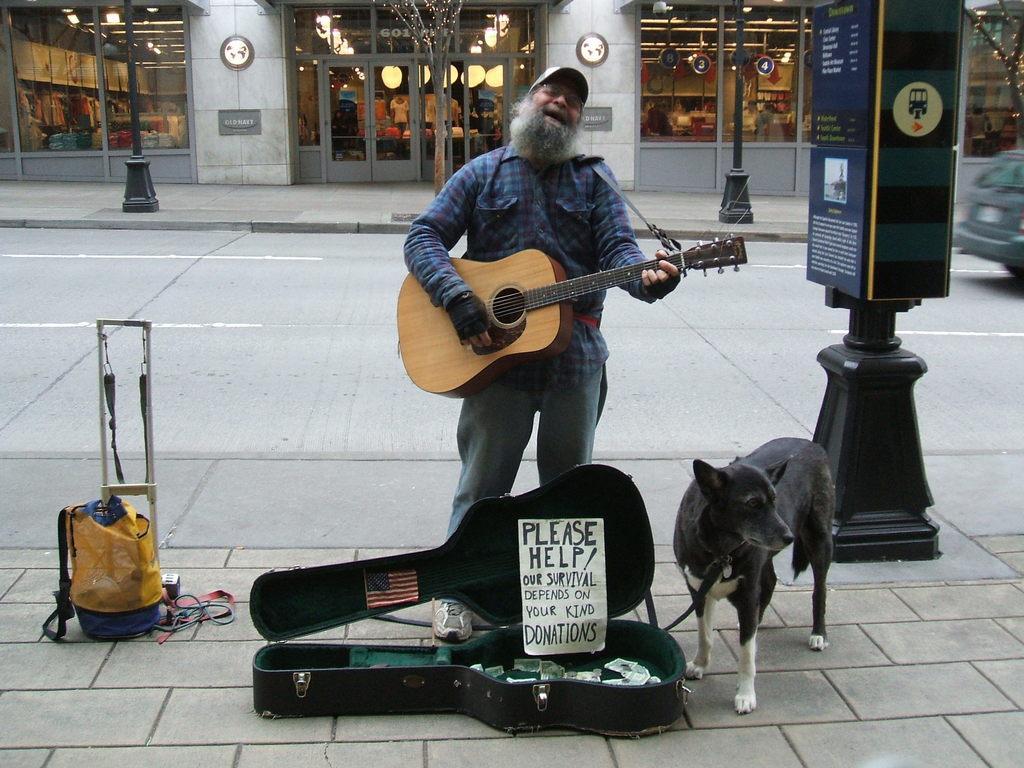Please provide a concise description of this image. In this image i can see a person wearing a hat , blue shirt and blue jeans standing and holding a guitar, i can see a guitar box with few objects, a flag and a paper and a dog standing beside him. In the background i can see road, a car, a tree, few poles and the building. 